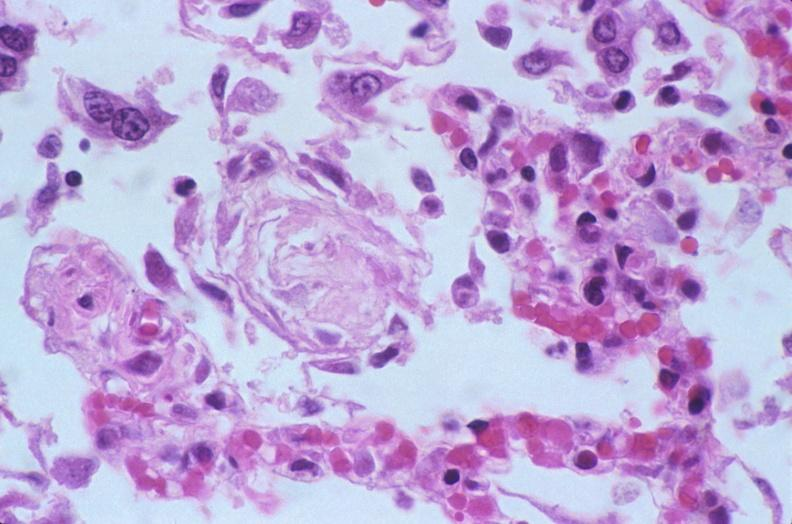does thymus show lung, diffuse alveolar damage?
Answer the question using a single word or phrase. No 